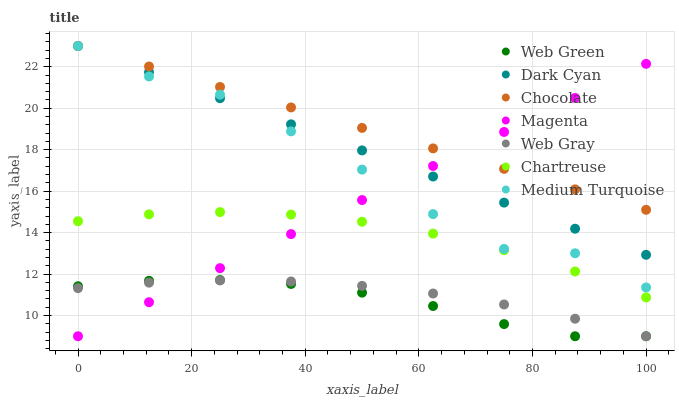Does Web Green have the minimum area under the curve?
Answer yes or no. Yes. Does Chocolate have the maximum area under the curve?
Answer yes or no. Yes. Does Chocolate have the minimum area under the curve?
Answer yes or no. No. Does Web Green have the maximum area under the curve?
Answer yes or no. No. Is Dark Cyan the smoothest?
Answer yes or no. Yes. Is Medium Turquoise the roughest?
Answer yes or no. Yes. Is Web Green the smoothest?
Answer yes or no. No. Is Web Green the roughest?
Answer yes or no. No. Does Web Gray have the lowest value?
Answer yes or no. Yes. Does Chocolate have the lowest value?
Answer yes or no. No. Does Dark Cyan have the highest value?
Answer yes or no. Yes. Does Web Green have the highest value?
Answer yes or no. No. Is Web Gray less than Chocolate?
Answer yes or no. Yes. Is Dark Cyan greater than Web Gray?
Answer yes or no. Yes. Does Chocolate intersect Medium Turquoise?
Answer yes or no. Yes. Is Chocolate less than Medium Turquoise?
Answer yes or no. No. Is Chocolate greater than Medium Turquoise?
Answer yes or no. No. Does Web Gray intersect Chocolate?
Answer yes or no. No. 